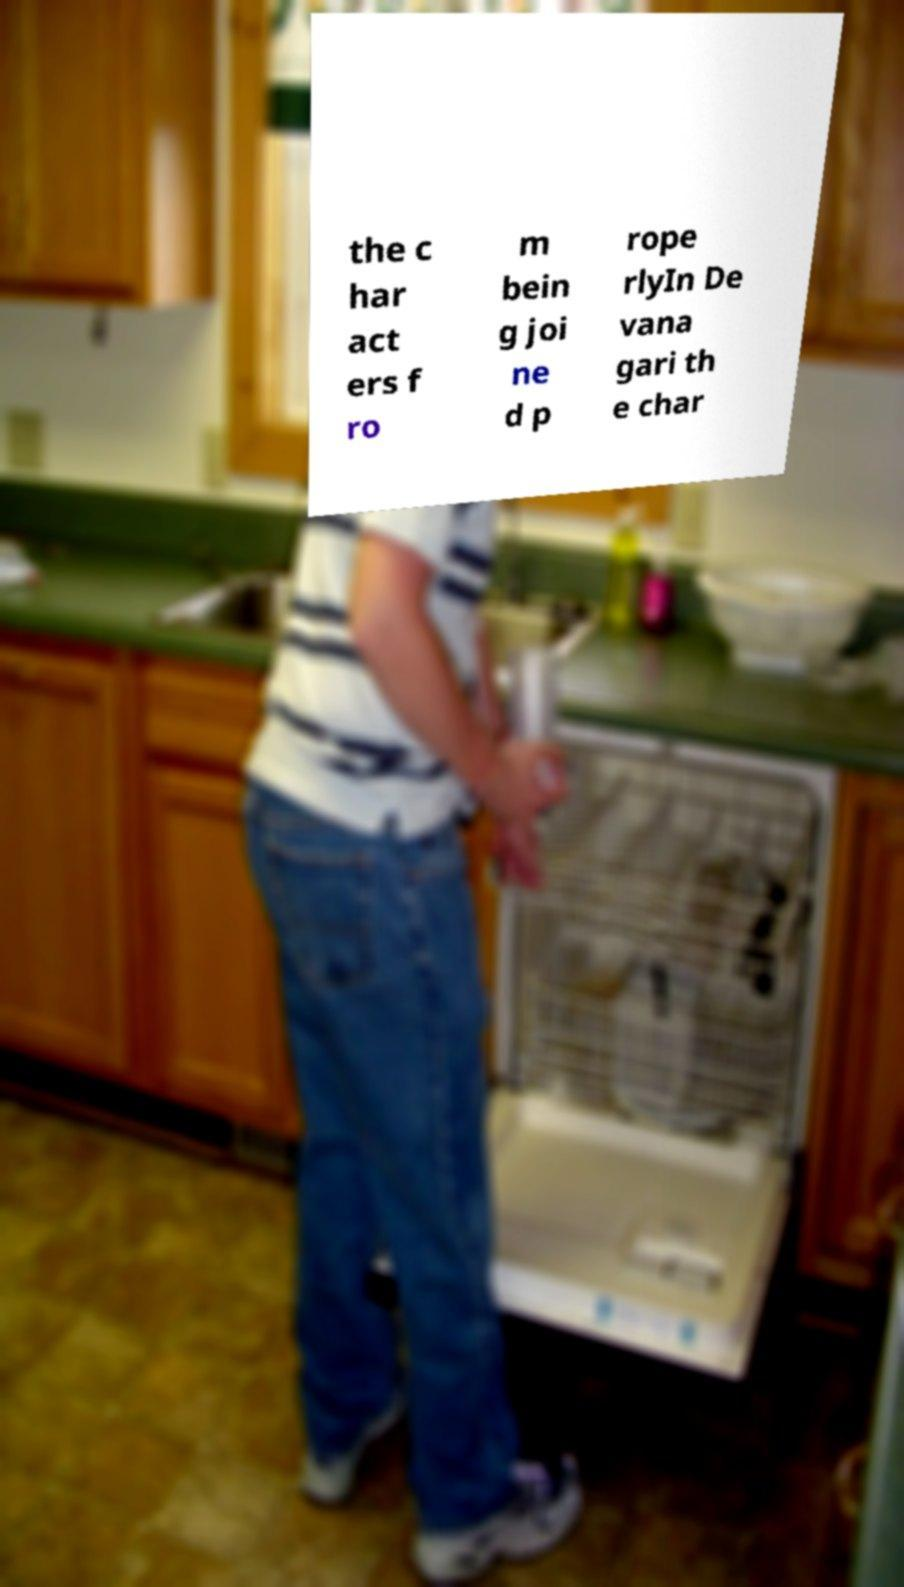I need the written content from this picture converted into text. Can you do that? the c har act ers f ro m bein g joi ne d p rope rlyIn De vana gari th e char 